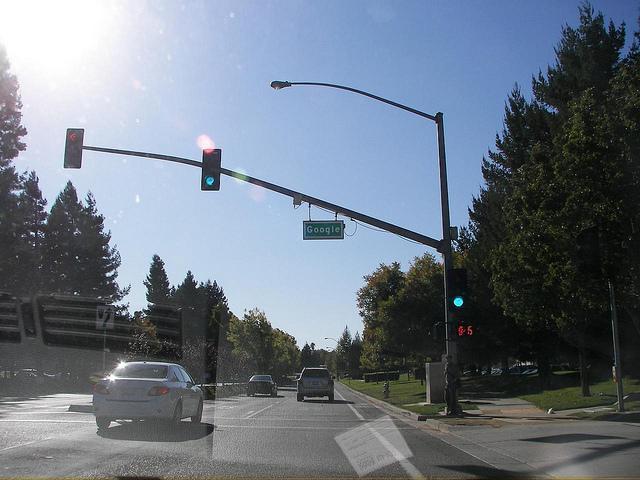How many ski poles are there?
Give a very brief answer. 0. 